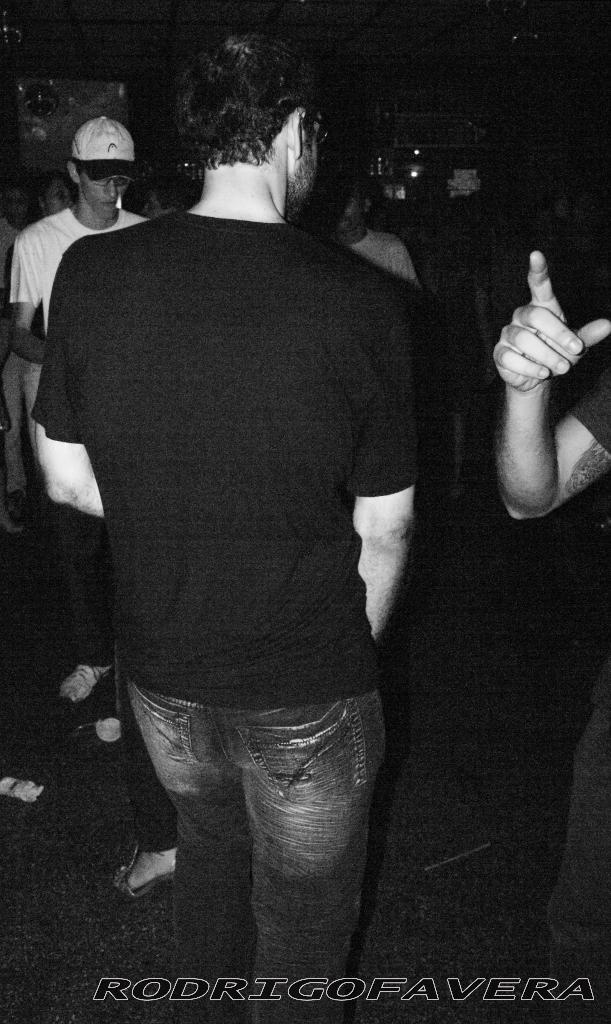What is the color scheme of the image? The image is black and white. What can be seen in the foreground of the image? There are people standing in the image. Where are the people standing? The people are standing on the floor. Can you describe the background of the image? The background of the image is not clear, but there are objects visible in it. What type of tools does the carpenter use in the image? There is no carpenter present in the image, and therefore no tools can be observed. What kind of humor can be found in the image? There is no humor present in the image; it is a straightforward depiction of people standing on the floor. 